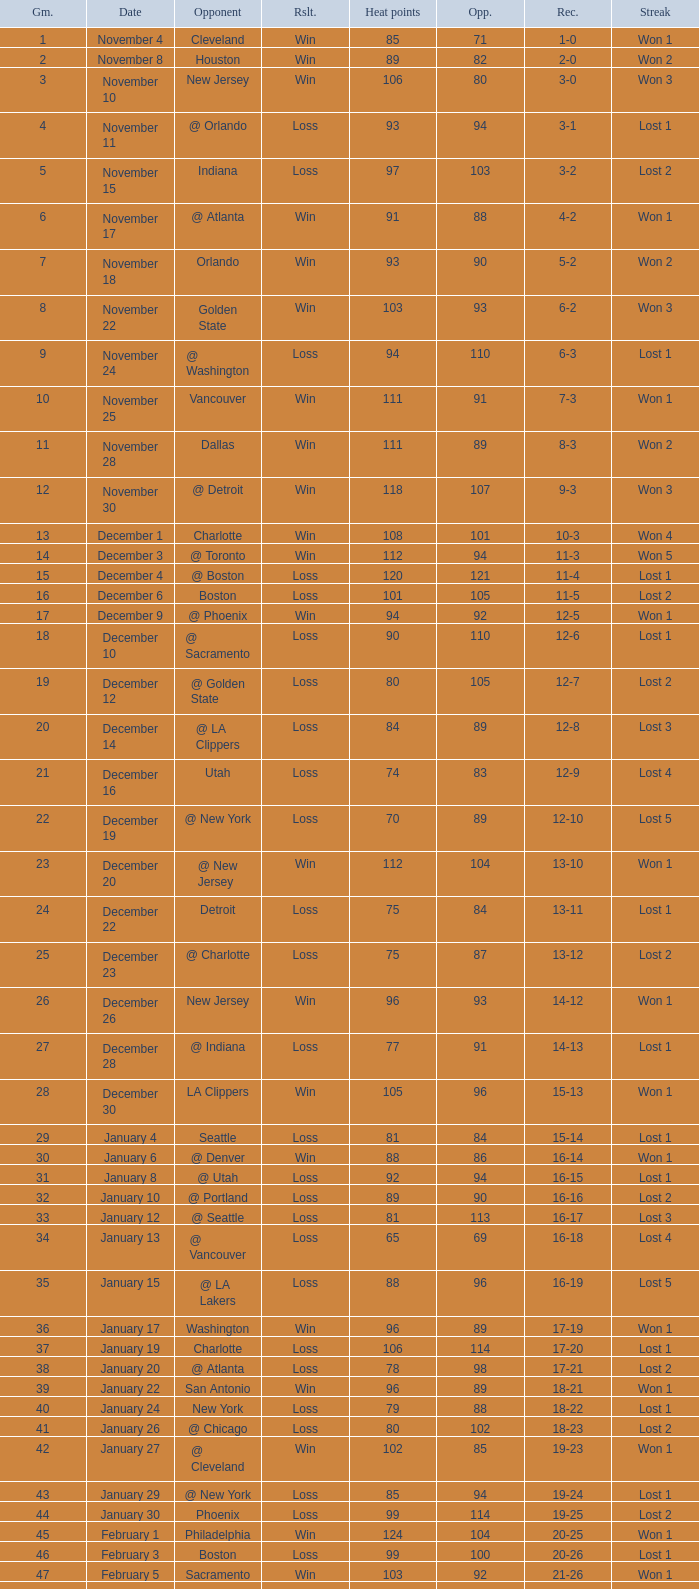What is Result, when Date is "December 12"? Loss. 